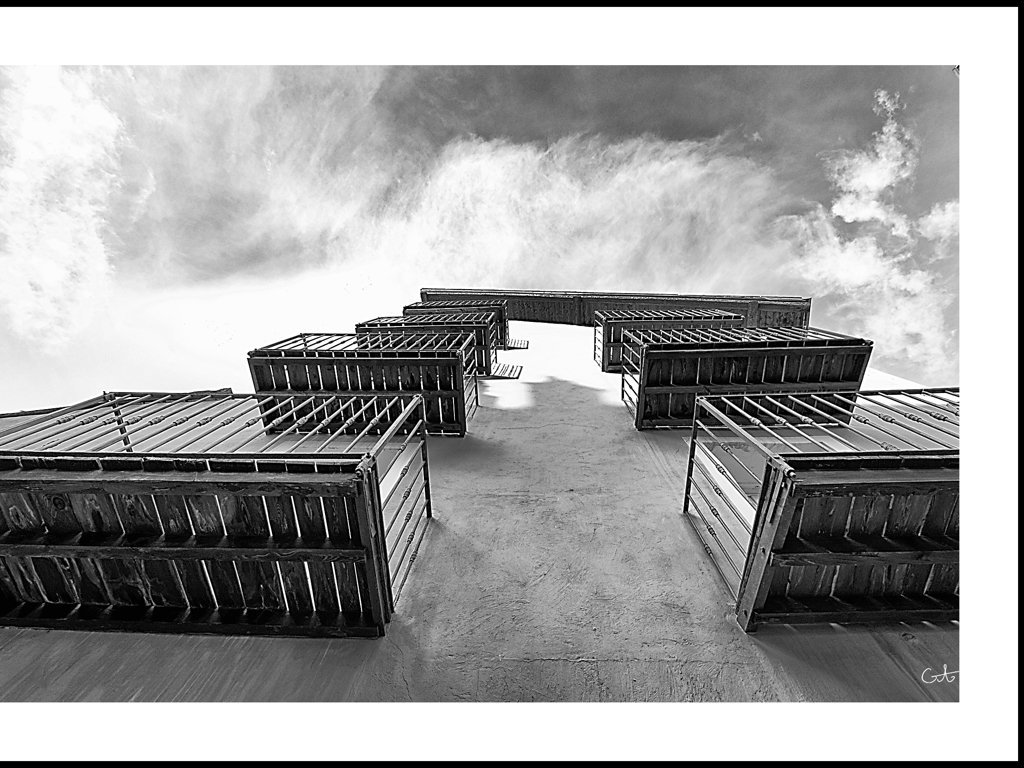Can you tell me more about the architectural style featured in the image? The architecture in the image features strong geometrical lines and rectangular forms which are characteristic of modern architectural styles. The use of repeating patterns and the emphasis on the structural form over ornamentation suggest functionality and a contemporary aesthetic. 